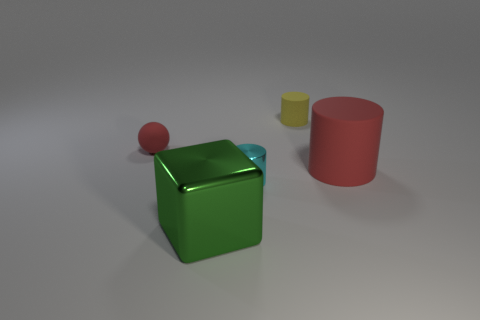The cyan thing has what size?
Your answer should be compact. Small. What shape is the tiny shiny thing?
Ensure brevity in your answer.  Cylinder. There is a matte cylinder in front of the red sphere; is its color the same as the tiny sphere?
Offer a very short reply. Yes. What is the size of the red thing that is the same shape as the small cyan thing?
Give a very brief answer. Large. There is a tiny cylinder behind the tiny rubber thing that is left of the large green thing; is there a red rubber thing that is right of it?
Your answer should be compact. Yes. What material is the large object that is in front of the tiny cyan metal cylinder?
Ensure brevity in your answer.  Metal. How many large things are green metal blocks or purple shiny things?
Make the answer very short. 1. There is a red thing on the right side of the green object; is its size the same as the green block?
Provide a succinct answer. Yes. How many other things are there of the same color as the small matte cylinder?
Provide a short and direct response. 0. What is the material of the yellow thing?
Offer a very short reply. Rubber. 